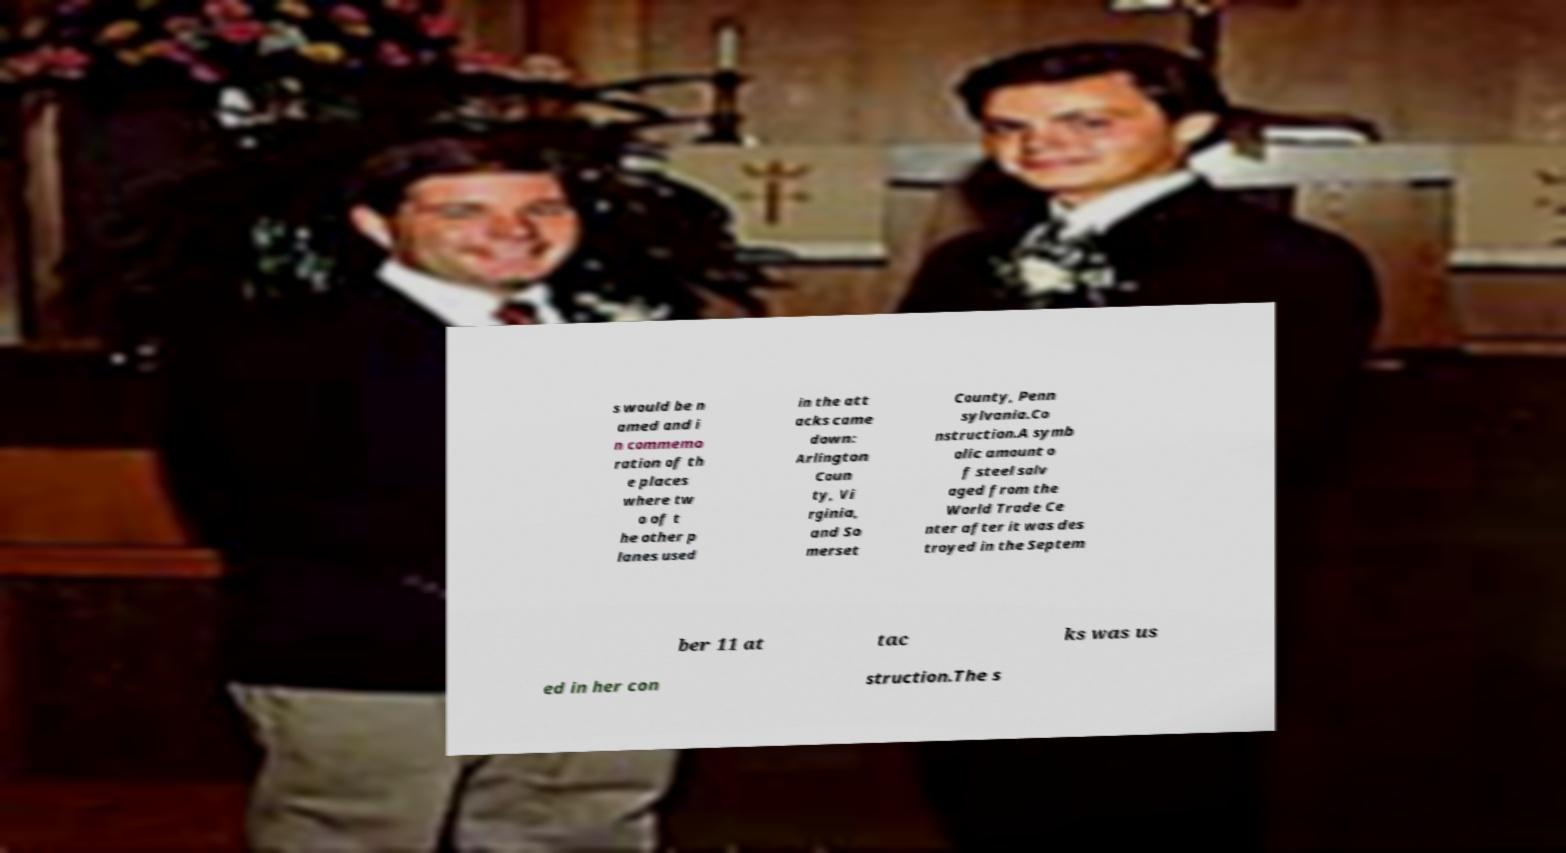Could you extract and type out the text from this image? s would be n amed and i n commemo ration of th e places where tw o of t he other p lanes used in the att acks came down: Arlington Coun ty, Vi rginia, and So merset County, Penn sylvania.Co nstruction.A symb olic amount o f steel salv aged from the World Trade Ce nter after it was des troyed in the Septem ber 11 at tac ks was us ed in her con struction.The s 